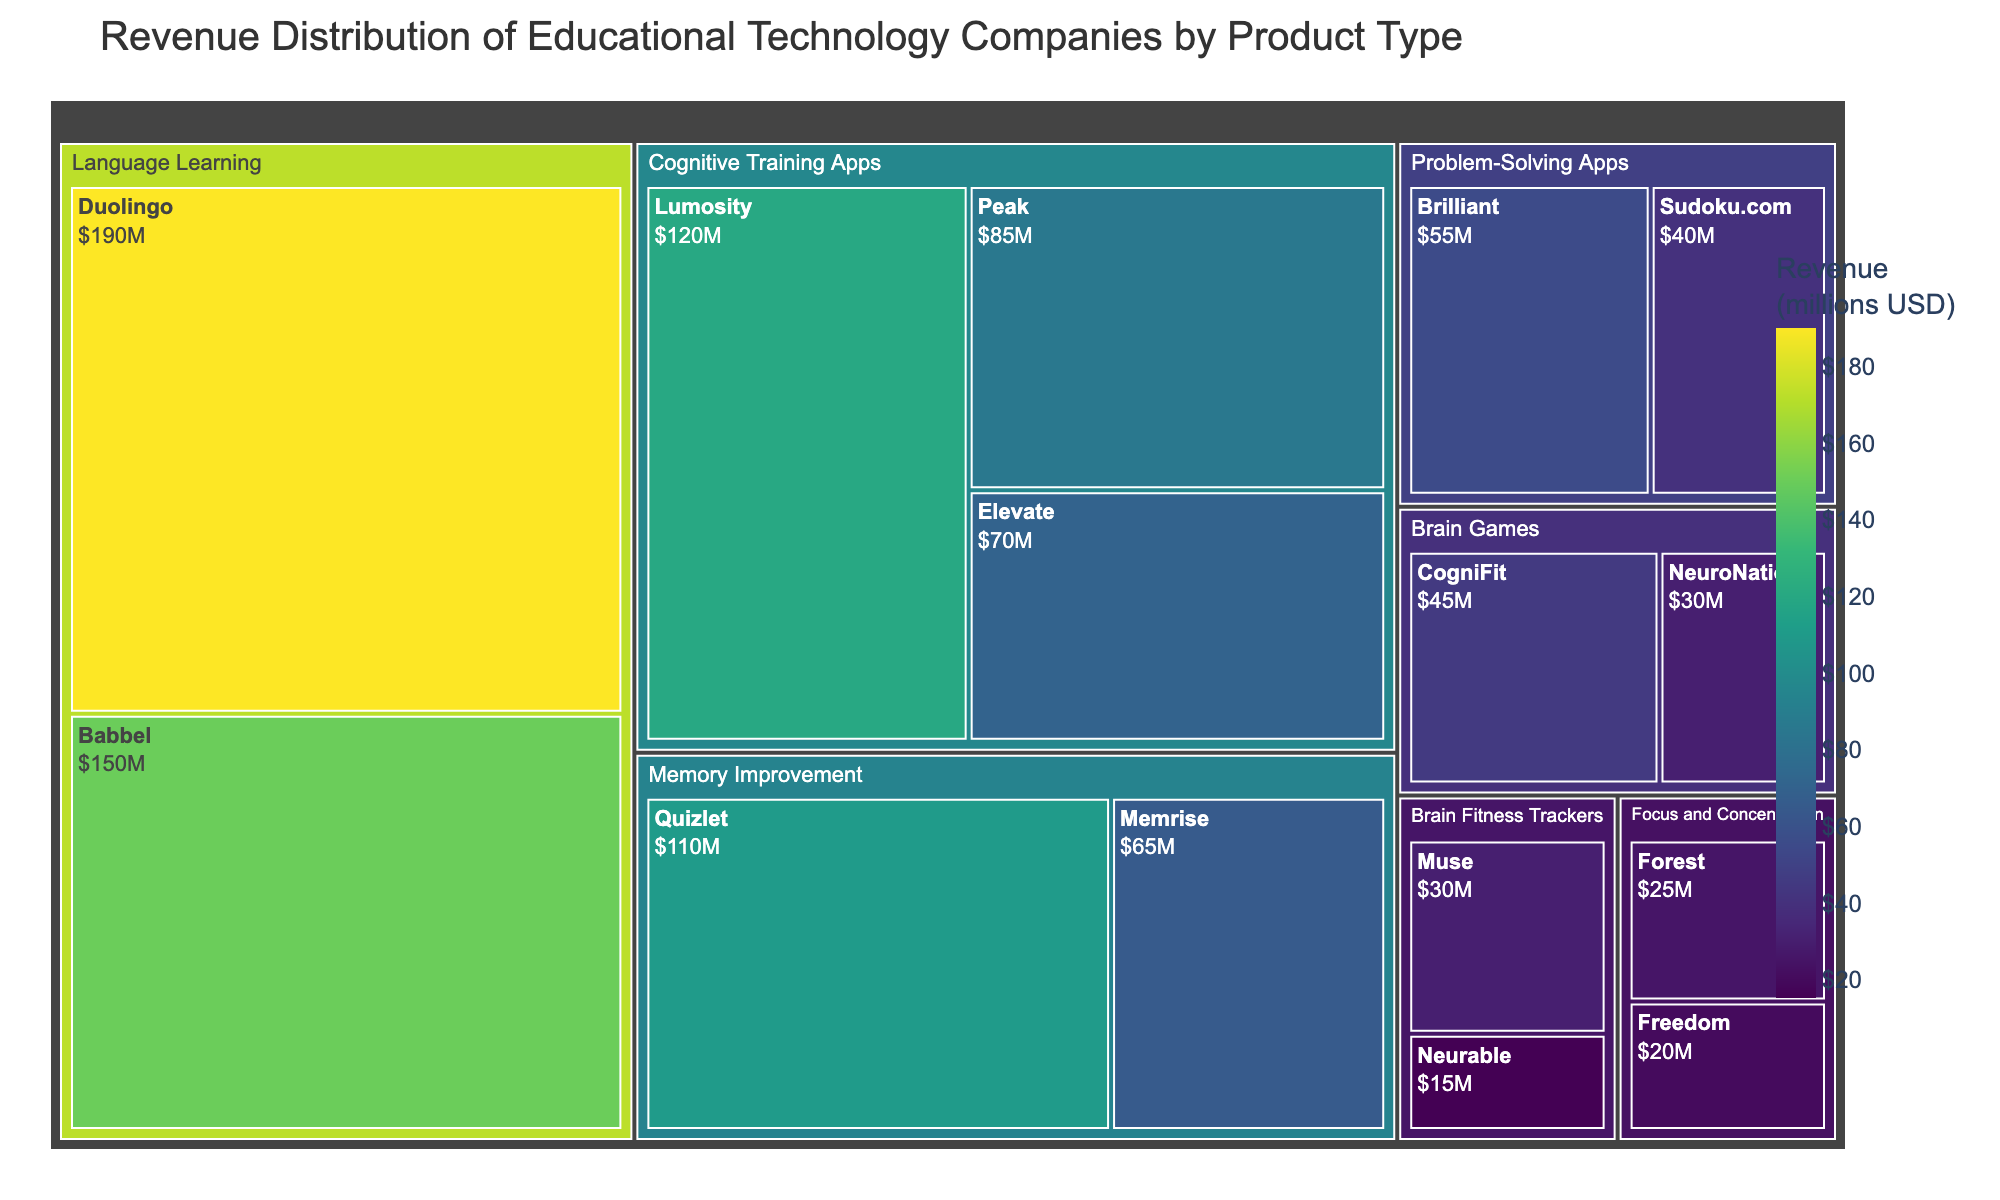Which product type has the highest total revenue? Summing up the revenues for each product type, "Language Learning" has the highest total revenue.
Answer: Language Learning How much is the combined revenue of Lumosity and Peak? The revenue of Lumosity is 120 million USD and that of Peak is 85 million USD, so their combined revenue is 120 + 85 = 205 million USD.
Answer: 205 million USD Which company has the lowest revenue in the "Focus and Concentration" category? There are two companies in the "Focus and Concentration" category: Forest with 25 million USD and Freedom with 20 million USD. Thus, Freedom has the lowest revenue.
Answer: Freedom What is the revenue difference between Duolingo and Babbel? Duolingo has a revenue of 190 million USD, and Babbel has a revenue of 150 million USD. The difference is 190 - 150 = 40 million USD.
Answer: 40 million USD Which product type has more companies, "Brain Games" or "Memory Improvement"? "Brain Games" has 2 companies: CogniFit and NeuroNation. "Memory Improvement" also has 2 companies: Memrise and Quizlet. Hence, both have the same number of companies.
Answer: Both have the same number of companies What's the sum of revenues for companies under "Brain Fitness Trackers"? The companies under "Brain Fitness Trackers" are Neurable with 15 million USD and Muse with 30 million USD. The sum is 15 + 30 = 45 million USD.
Answer: 45 million USD Compare the revenues of Memrise and Quizlet. Which one is higher? Memrise has a revenue of 65 million USD, and Quizlet has 110 million USD. Quizlet's revenue is higher than Memrise's.
Answer: Quizlet What is the average revenue of companies in the "Language Learning" category? The "Language Learning" category has 2 companies: Duolingo with 190 million USD and Babbel with 150 million USD. The average revenue is (190 + 150) / 2 = 170 million USD.
Answer: 170 million USD Which company has the highest revenue in the "Cognitive Training Apps" category? Among "Cognitive Training Apps," Lumosity has the highest revenue with 120 million USD.
Answer: Lumosity Is the revenue of Brilliant more than that of Sudoku.com? Brilliant has a revenue of 55 million USD, whereas Sudoku.com has 40 million USD. Brilliant's revenue is higher.
Answer: Yes 